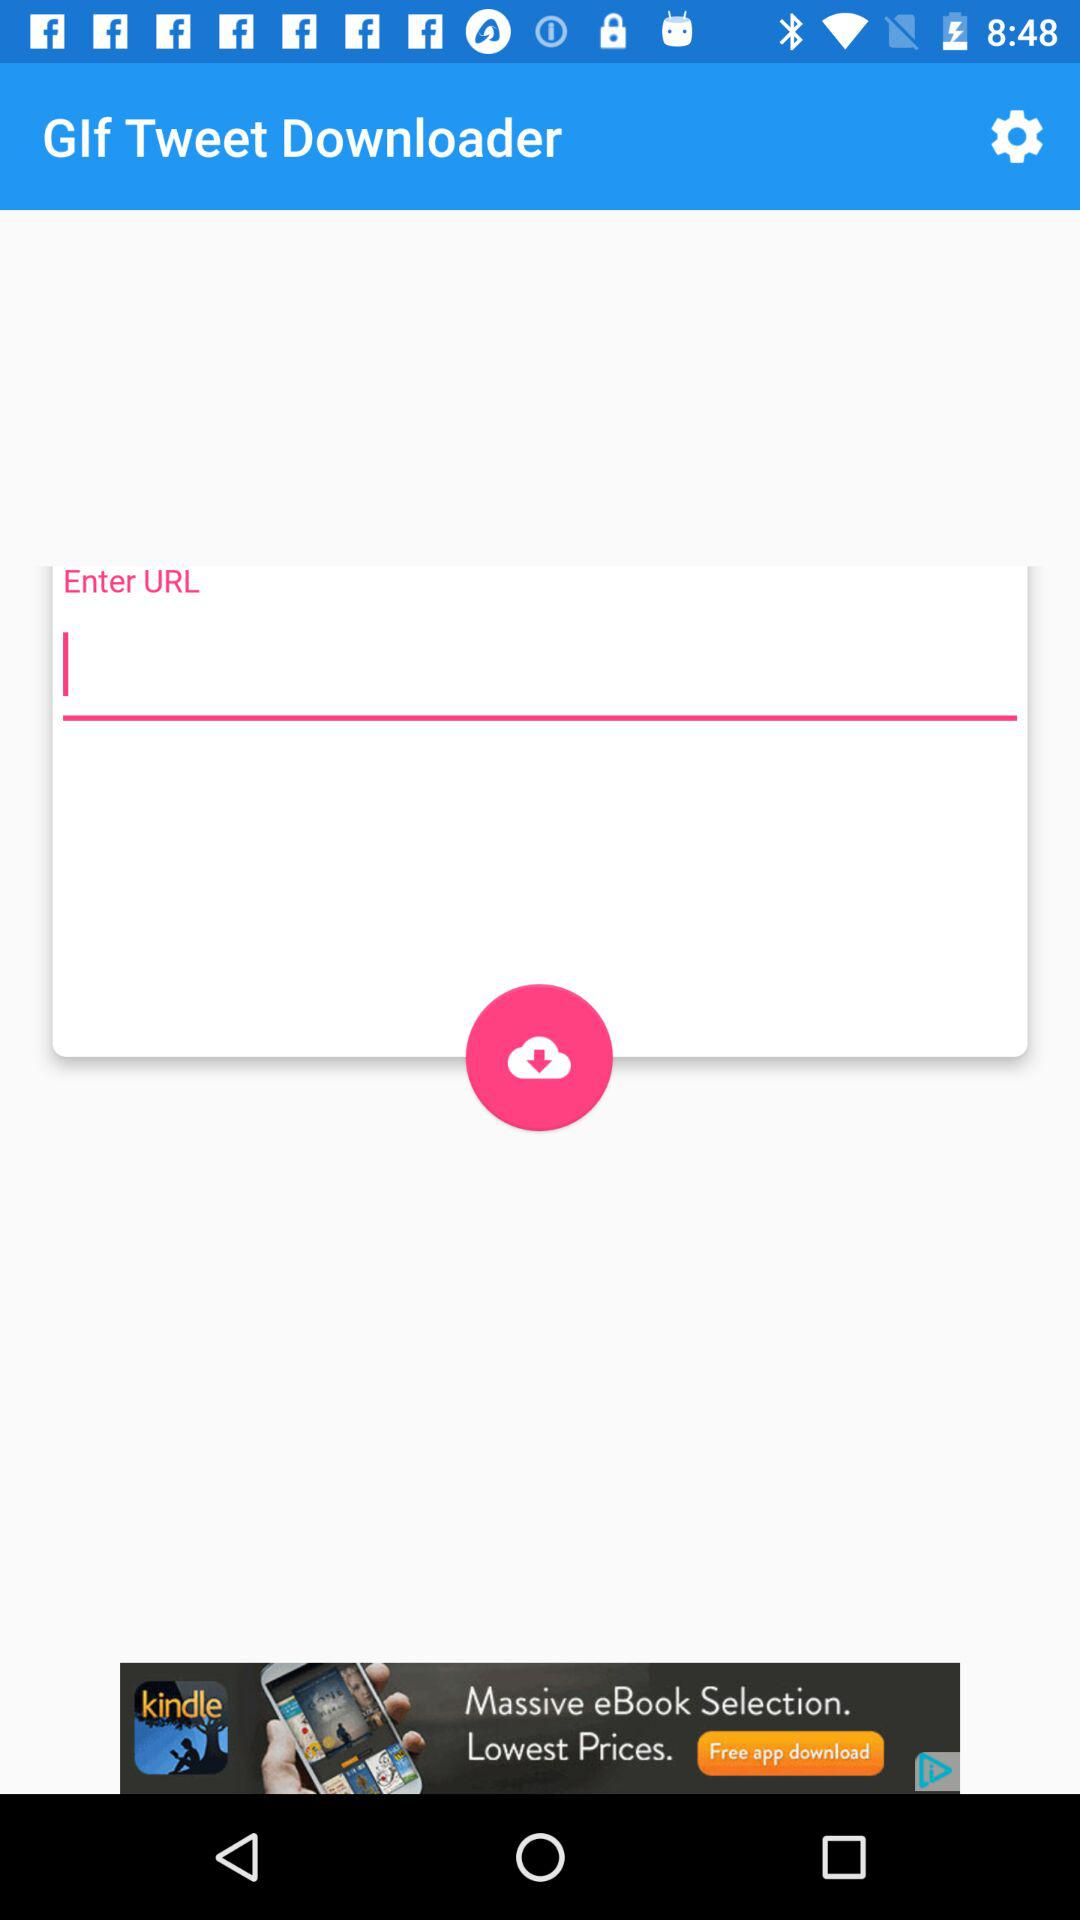What is the application name? The application name is "GIf Tweet Downloader". 